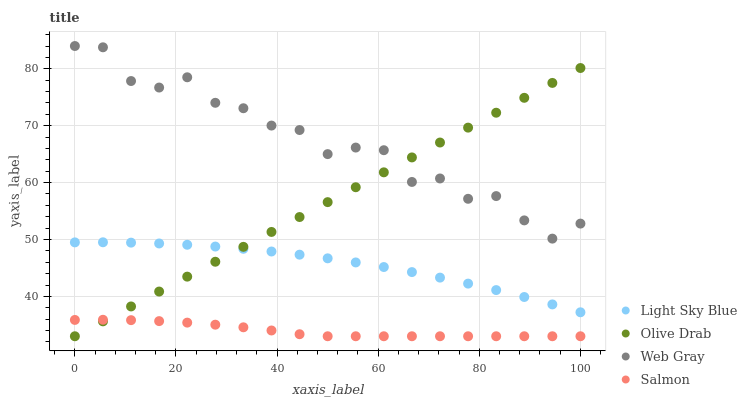Does Salmon have the minimum area under the curve?
Answer yes or no. Yes. Does Web Gray have the maximum area under the curve?
Answer yes or no. Yes. Does Light Sky Blue have the minimum area under the curve?
Answer yes or no. No. Does Light Sky Blue have the maximum area under the curve?
Answer yes or no. No. Is Olive Drab the smoothest?
Answer yes or no. Yes. Is Web Gray the roughest?
Answer yes or no. Yes. Is Light Sky Blue the smoothest?
Answer yes or no. No. Is Light Sky Blue the roughest?
Answer yes or no. No. Does Salmon have the lowest value?
Answer yes or no. Yes. Does Light Sky Blue have the lowest value?
Answer yes or no. No. Does Web Gray have the highest value?
Answer yes or no. Yes. Does Light Sky Blue have the highest value?
Answer yes or no. No. Is Salmon less than Light Sky Blue?
Answer yes or no. Yes. Is Web Gray greater than Salmon?
Answer yes or no. Yes. Does Web Gray intersect Olive Drab?
Answer yes or no. Yes. Is Web Gray less than Olive Drab?
Answer yes or no. No. Is Web Gray greater than Olive Drab?
Answer yes or no. No. Does Salmon intersect Light Sky Blue?
Answer yes or no. No. 